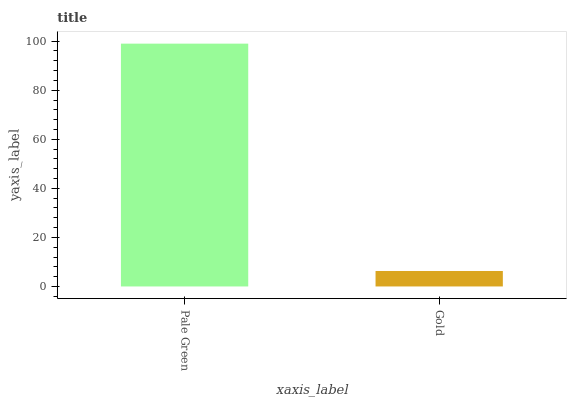Is Gold the minimum?
Answer yes or no. Yes. Is Pale Green the maximum?
Answer yes or no. Yes. Is Gold the maximum?
Answer yes or no. No. Is Pale Green greater than Gold?
Answer yes or no. Yes. Is Gold less than Pale Green?
Answer yes or no. Yes. Is Gold greater than Pale Green?
Answer yes or no. No. Is Pale Green less than Gold?
Answer yes or no. No. Is Pale Green the high median?
Answer yes or no. Yes. Is Gold the low median?
Answer yes or no. Yes. Is Gold the high median?
Answer yes or no. No. Is Pale Green the low median?
Answer yes or no. No. 